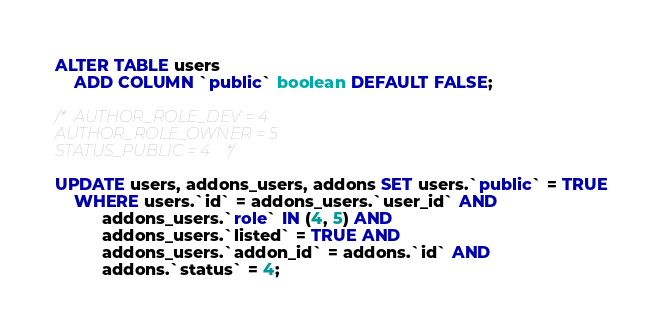<code> <loc_0><loc_0><loc_500><loc_500><_SQL_>ALTER TABLE users
    ADD COLUMN `public` boolean DEFAULT FALSE;

/* AUTHOR_ROLE_DEV = 4
AUTHOR_ROLE_OWNER = 5
STATUS_PUBLIC = 4 */

UPDATE users, addons_users, addons SET users.`public` = TRUE
    WHERE users.`id` = addons_users.`user_id` AND
          addons_users.`role` IN (4, 5) AND
          addons_users.`listed` = TRUE AND
          addons_users.`addon_id` = addons.`id` AND
          addons.`status` = 4;
</code> 